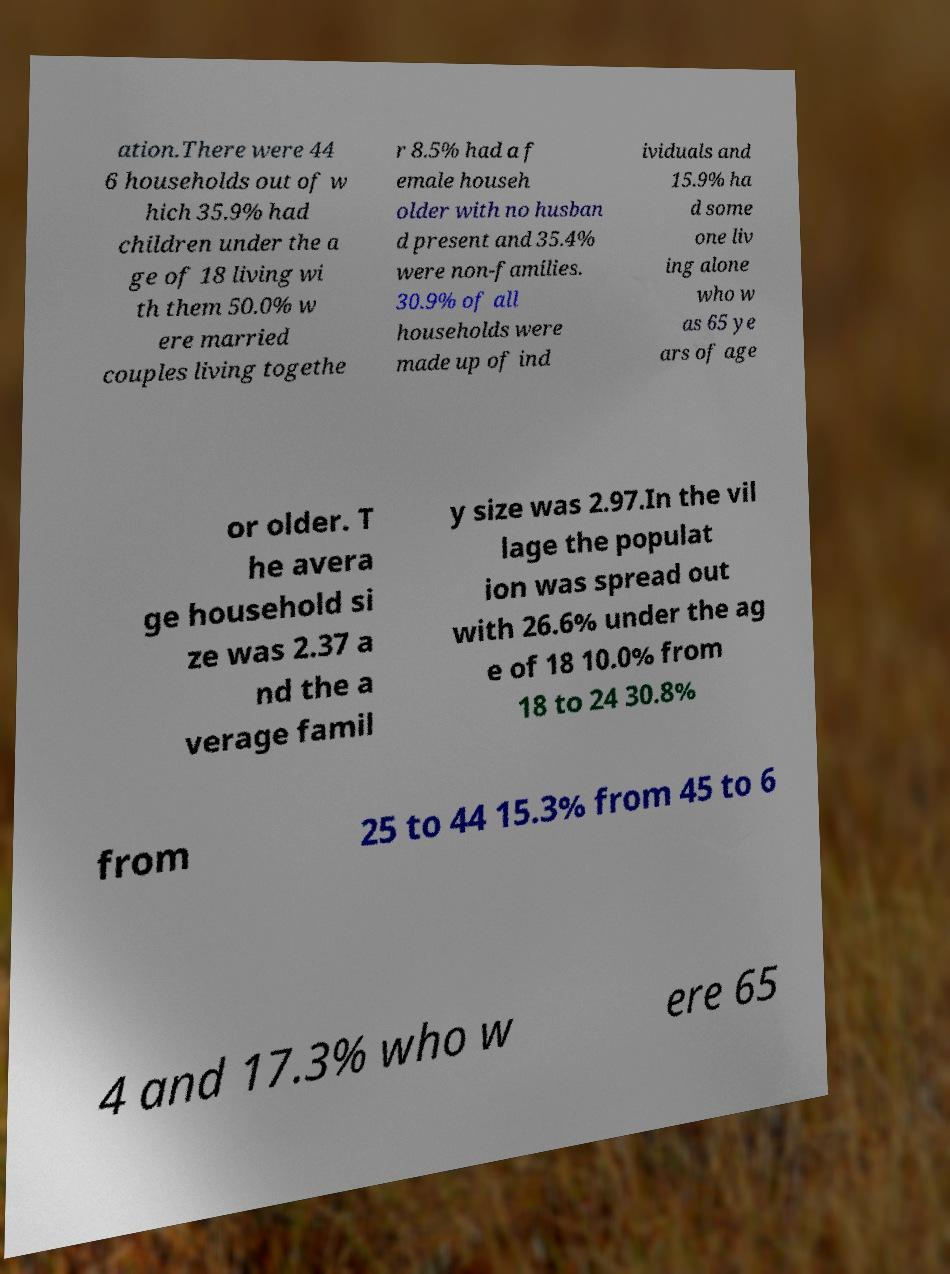What messages or text are displayed in this image? I need them in a readable, typed format. ation.There were 44 6 households out of w hich 35.9% had children under the a ge of 18 living wi th them 50.0% w ere married couples living togethe r 8.5% had a f emale househ older with no husban d present and 35.4% were non-families. 30.9% of all households were made up of ind ividuals and 15.9% ha d some one liv ing alone who w as 65 ye ars of age or older. T he avera ge household si ze was 2.37 a nd the a verage famil y size was 2.97.In the vil lage the populat ion was spread out with 26.6% under the ag e of 18 10.0% from 18 to 24 30.8% from 25 to 44 15.3% from 45 to 6 4 and 17.3% who w ere 65 